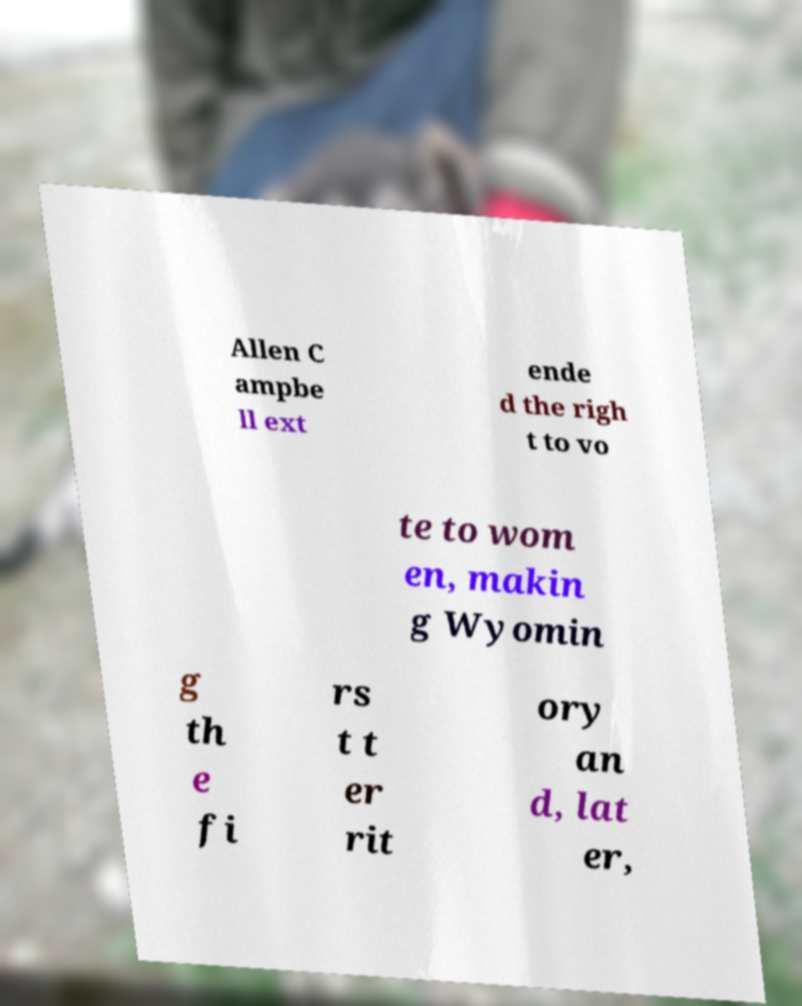What messages or text are displayed in this image? I need them in a readable, typed format. Allen C ampbe ll ext ende d the righ t to vo te to wom en, makin g Wyomin g th e fi rs t t er rit ory an d, lat er, 